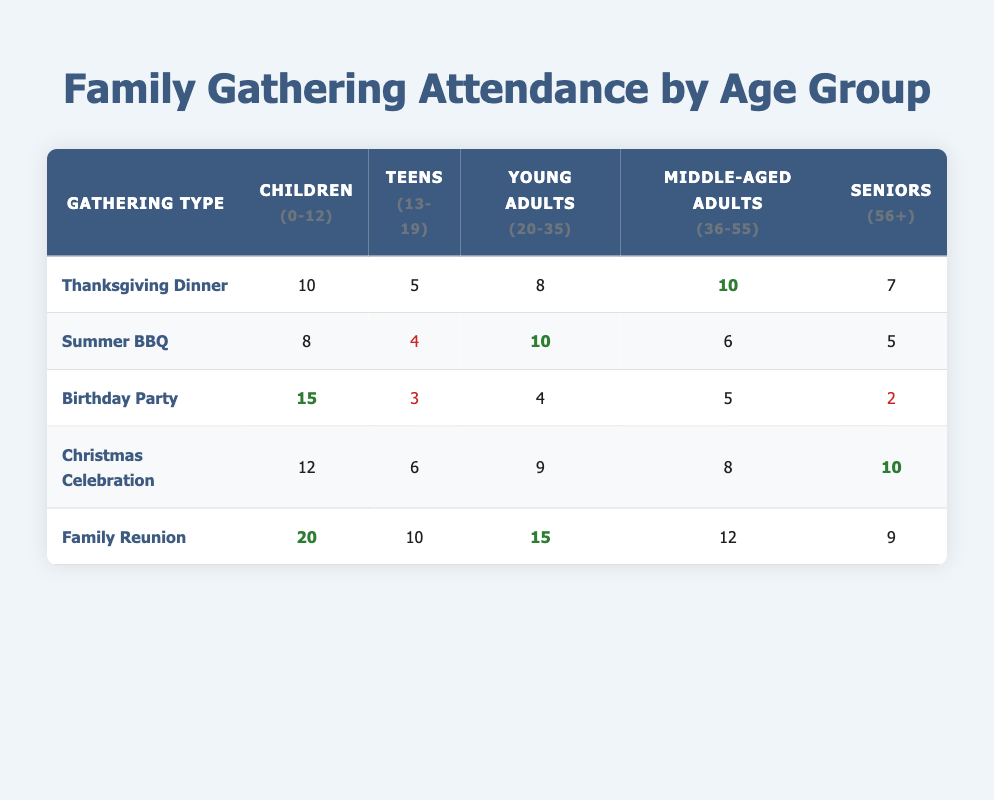What is the attendance of Seniors at the Thanksgiving Dinner? Referring to the table, the column for Seniors under Thanksgiving Dinner shows a value of 7.
Answer: 7 How many Teens attended the Family Reunion compared to the Birthday Party? The Family Reunion had 10 Teens while the Birthday Party had 3 Teens. The difference is 10 - 3 = 7.
Answer: 7 What is the combined attendance of Young Adults at the Summer BBQ and Christmas Celebration? The Summer BBQ showed attendance of 10 Young Adults and Christmas Celebration had 9. Adding them together gives: 10 + 9 = 19.
Answer: 19 Did more Children attend the Birthday Party than the Thanksgiving Dinner? The Birthday Party had 15 Children while the Thanksgiving Dinner had 10 Children. Since 15 is greater than 10, the statement is true.
Answer: Yes What is the total attendance of Children across all gatherings? Adding the number of Children from all gatherings: 10 + 8 + 15 + 12 + 20 = 65.
Answer: 65 Which gathering had the highest attendance of Middle-Aged Adults? Reviewing the Middle-Aged Adults column, the Family Reunion has the highest number at 12, compared to others: 10 (Thanksgiving), 6 (Summer BBQ), 5 (Birthday Party), and 8 (Christmas).
Answer: Family Reunion What age group had the lowest attendance overall at the Birthday Party? The Birthday Party had 15 Children, 3 Teens, 4 Young Adults, 5 Middle-Aged Adults, and 2 Seniors. The lowest attended group is Seniors with 2.
Answer: Seniors Which gathering had more overall attendees, Family Reunion or Thanksgiving Dinner? The Family Reunion had 20 Children, 10 Teens, 15 Young Adults, 12 Middle-Aged Adults, and 9 Seniors, giving a total of 66. The Thanksgiving Dinner had: 10 Children, 5 Teens, 8 Young Adults, 10 Middle-Aged Adults, and 7 Seniors, totaling 40. Thus, Family Reunion had more.
Answer: Family Reunion What was the average number of Teens attending across all the gatherings? Summing the Teens: 5 (Thanksgiving) + 4 (Summer BBQ) + 3 (Birthday Party) + 6 (Christmas) + 10 (Family Reunion) = 28. There are 5 gatherings, so the average is 28 / 5 = 5.6.
Answer: 5.6 